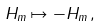<formula> <loc_0><loc_0><loc_500><loc_500>H _ { m } \mapsto - H _ { m } \, ,</formula> 